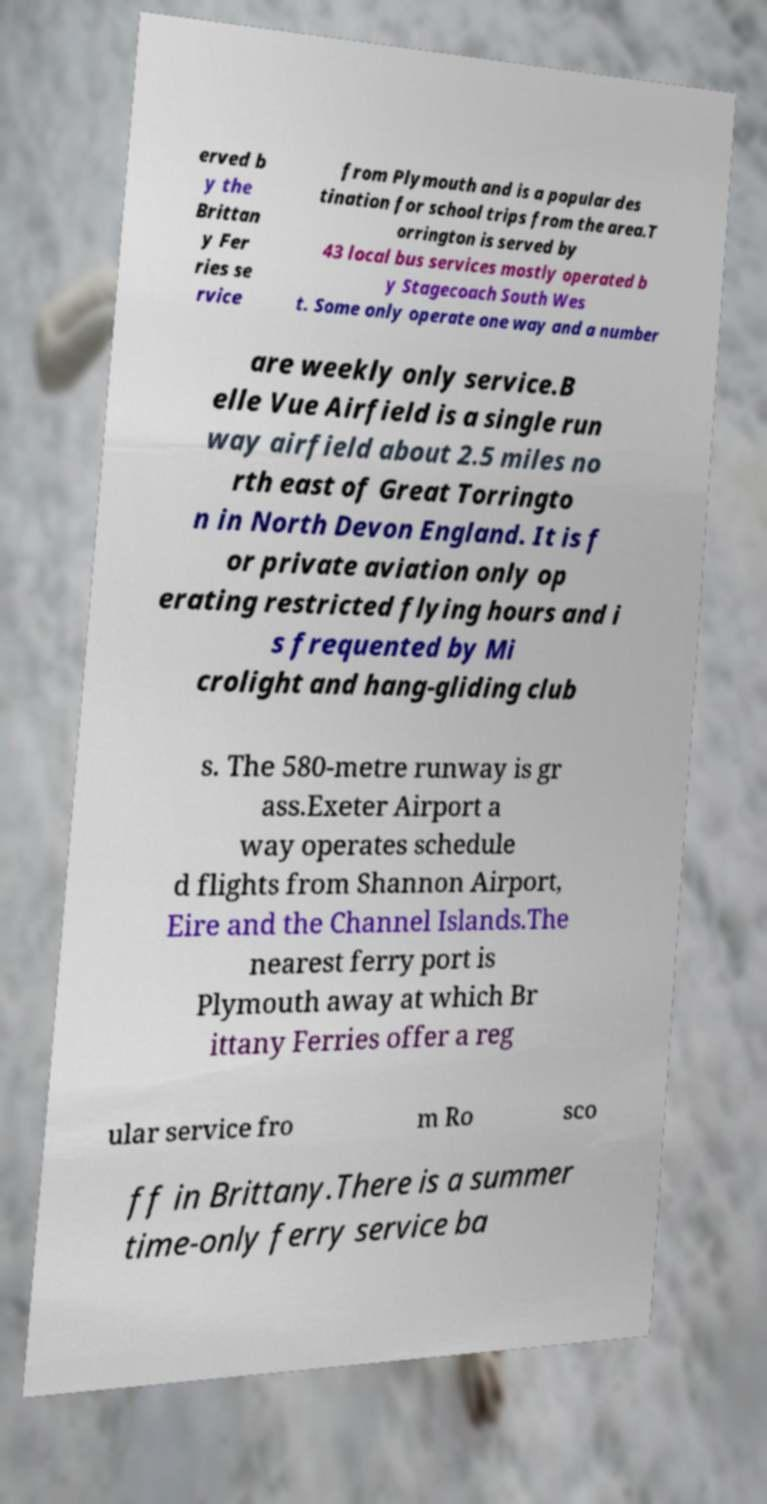What messages or text are displayed in this image? I need them in a readable, typed format. erved b y the Brittan y Fer ries se rvice from Plymouth and is a popular des tination for school trips from the area.T orrington is served by 43 local bus services mostly operated b y Stagecoach South Wes t. Some only operate one way and a number are weekly only service.B elle Vue Airfield is a single run way airfield about 2.5 miles no rth east of Great Torringto n in North Devon England. It is f or private aviation only op erating restricted flying hours and i s frequented by Mi crolight and hang-gliding club s. The 580-metre runway is gr ass.Exeter Airport a way operates schedule d flights from Shannon Airport, Eire and the Channel Islands.The nearest ferry port is Plymouth away at which Br ittany Ferries offer a reg ular service fro m Ro sco ff in Brittany.There is a summer time-only ferry service ba 